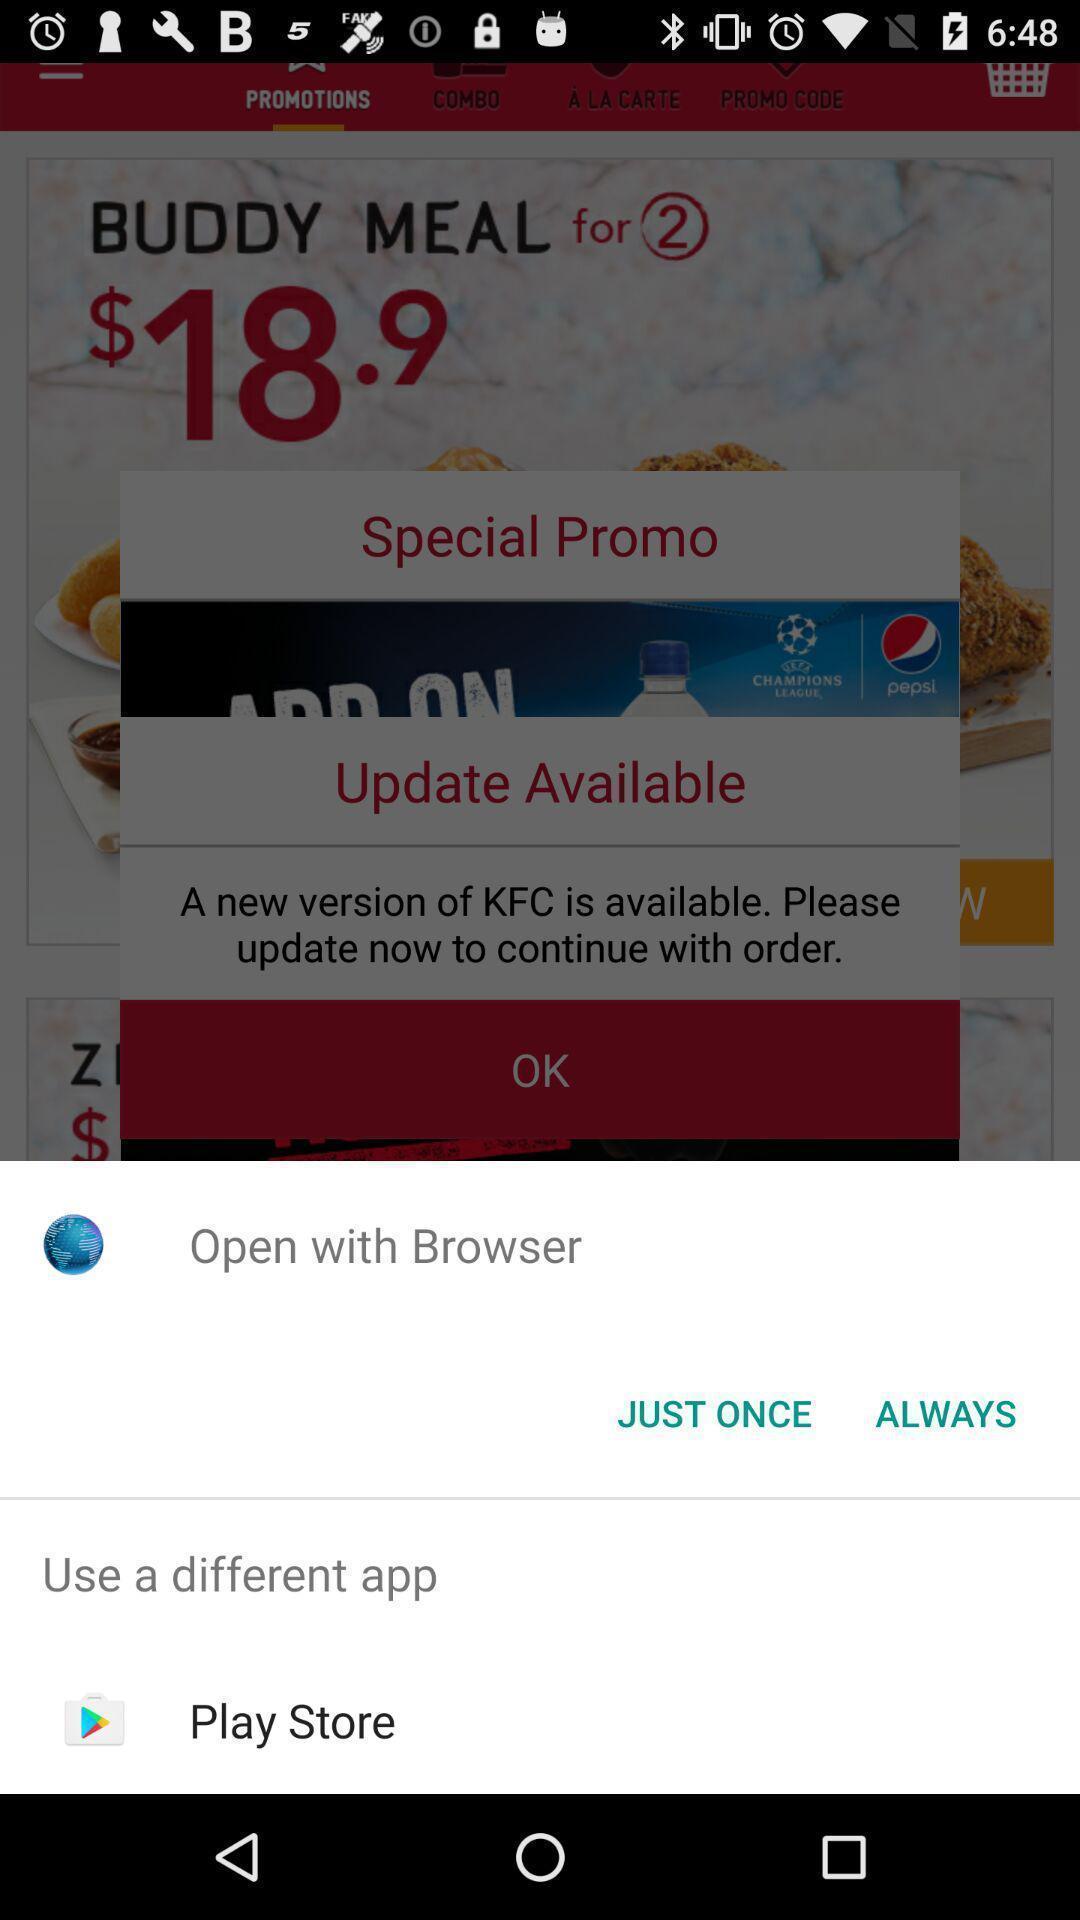Tell me what you see in this picture. Popup displaying multiple options to open an app with. 